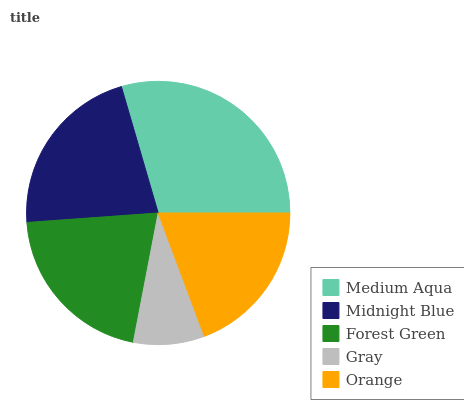Is Gray the minimum?
Answer yes or no. Yes. Is Medium Aqua the maximum?
Answer yes or no. Yes. Is Midnight Blue the minimum?
Answer yes or no. No. Is Midnight Blue the maximum?
Answer yes or no. No. Is Medium Aqua greater than Midnight Blue?
Answer yes or no. Yes. Is Midnight Blue less than Medium Aqua?
Answer yes or no. Yes. Is Midnight Blue greater than Medium Aqua?
Answer yes or no. No. Is Medium Aqua less than Midnight Blue?
Answer yes or no. No. Is Forest Green the high median?
Answer yes or no. Yes. Is Forest Green the low median?
Answer yes or no. Yes. Is Orange the high median?
Answer yes or no. No. Is Medium Aqua the low median?
Answer yes or no. No. 